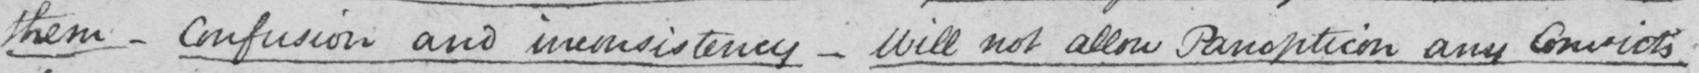Can you read and transcribe this handwriting? them  _  confusion and inconsistency  _  Will not allow Panopticon any Convicts 